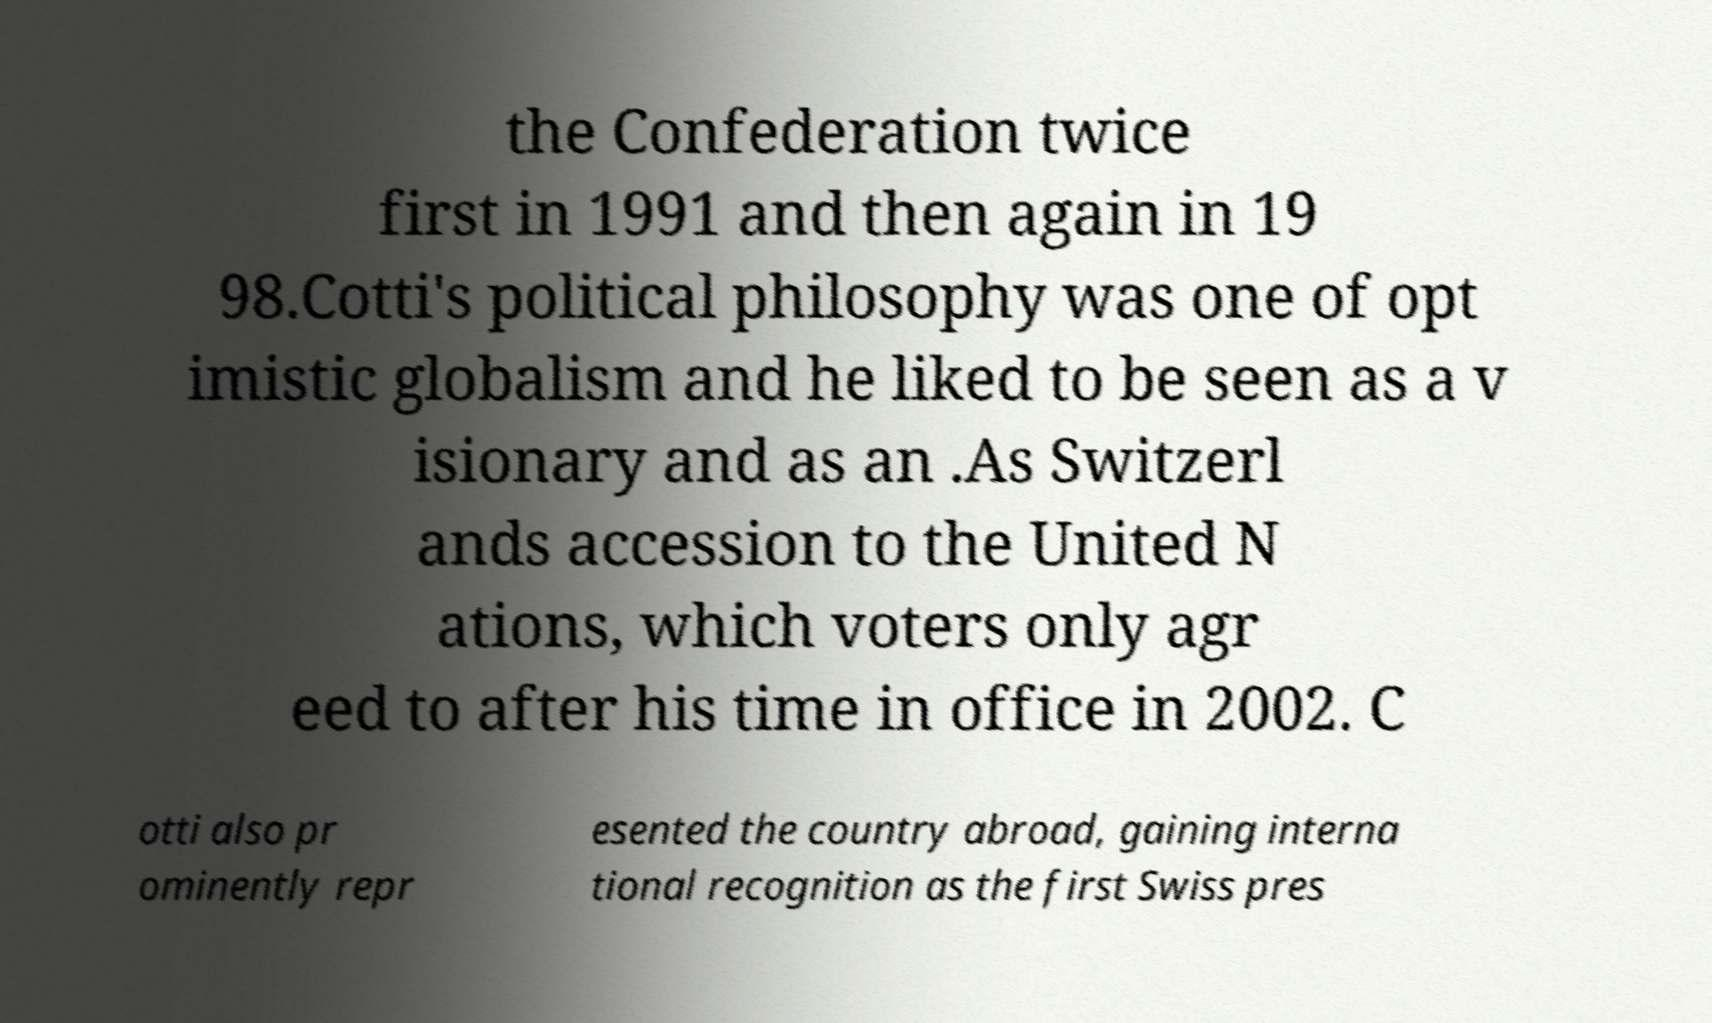Can you read and provide the text displayed in the image?This photo seems to have some interesting text. Can you extract and type it out for me? the Confederation twice first in 1991 and then again in 19 98.Cotti's political philosophy was one of opt imistic globalism and he liked to be seen as a v isionary and as an .As Switzerl ands accession to the United N ations, which voters only agr eed to after his time in office in 2002. C otti also pr ominently repr esented the country abroad, gaining interna tional recognition as the first Swiss pres 